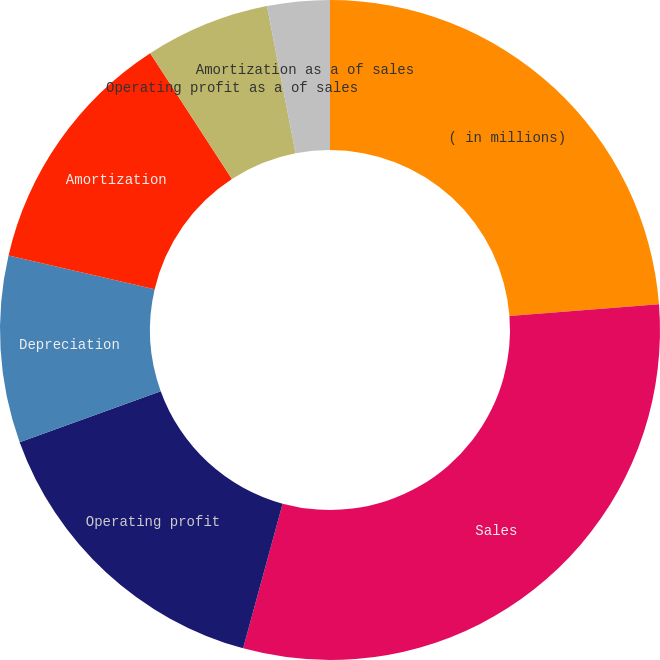<chart> <loc_0><loc_0><loc_500><loc_500><pie_chart><fcel>( in millions)<fcel>Sales<fcel>Operating profit<fcel>Depreciation<fcel>Amortization<fcel>Operating profit as a of sales<fcel>Depreciation as a of sales<fcel>Amortization as a of sales<nl><fcel>23.76%<fcel>30.48%<fcel>15.24%<fcel>9.15%<fcel>12.2%<fcel>6.1%<fcel>0.01%<fcel>3.06%<nl></chart> 